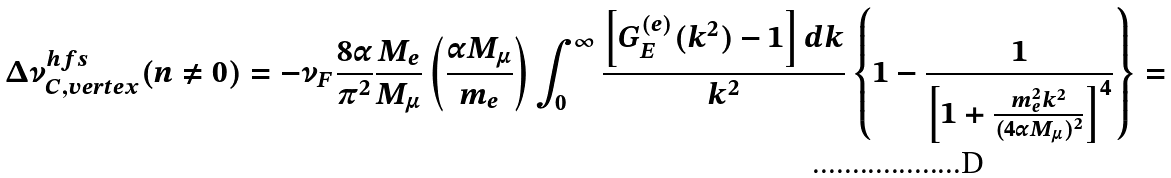<formula> <loc_0><loc_0><loc_500><loc_500>\Delta \nu ^ { h f s } _ { C , v e r t e x } ( n \not = 0 ) = - \nu _ { F } \frac { 8 \alpha } { \pi ^ { 2 } } \frac { M _ { e } } { M _ { \mu } } \left ( \frac { \alpha M _ { \mu } } { m _ { e } } \right ) \int _ { 0 } ^ { \infty } \frac { \left [ G _ { E } ^ { ( e ) } ( k ^ { 2 } ) - 1 \right ] d k } { k ^ { 2 } } \left \{ 1 - \frac { 1 } { \left [ 1 + \frac { m _ { e } ^ { 2 } k ^ { 2 } } { ( 4 \alpha M _ { \mu } ) ^ { 2 } } \right ] ^ { 4 } } \right \} =</formula> 